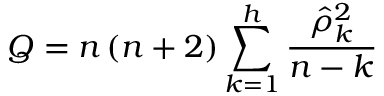<formula> <loc_0><loc_0><loc_500><loc_500>Q = n \left ( n + 2 \right ) \sum _ { k = 1 } ^ { h } { \frac { { \hat { \rho } } _ { k } ^ { 2 } } { n - k } }</formula> 